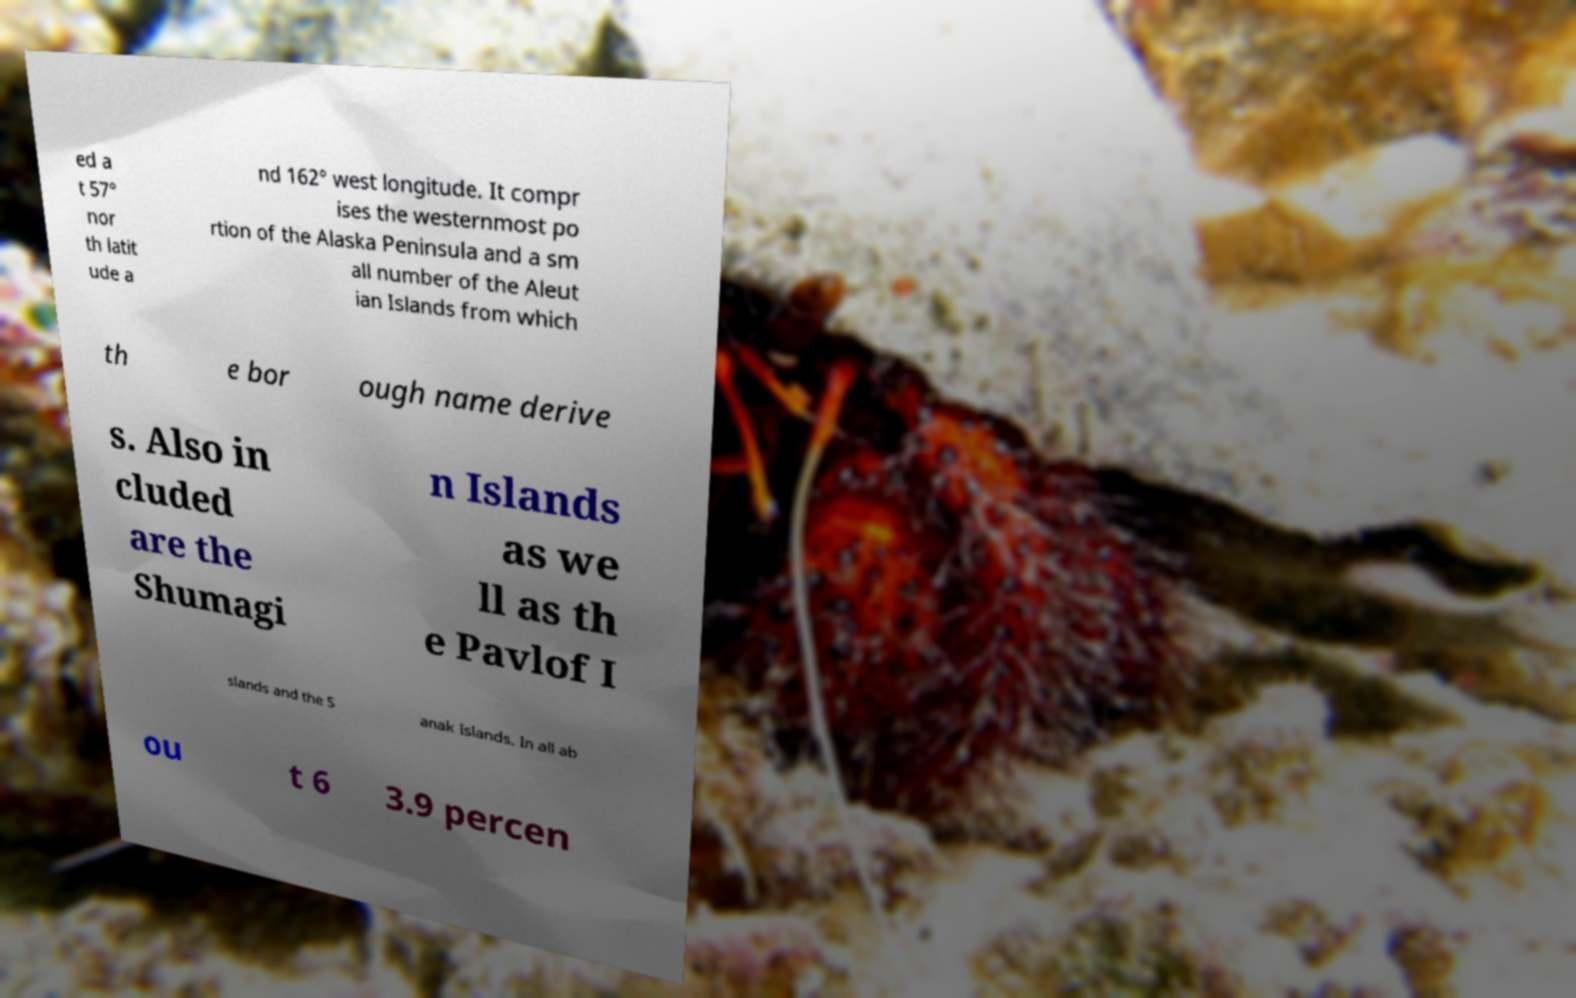There's text embedded in this image that I need extracted. Can you transcribe it verbatim? ed a t 57° nor th latit ude a nd 162° west longitude. It compr ises the westernmost po rtion of the Alaska Peninsula and a sm all number of the Aleut ian Islands from which th e bor ough name derive s. Also in cluded are the Shumagi n Islands as we ll as th e Pavlof I slands and the S anak Islands. In all ab ou t 6 3.9 percen 